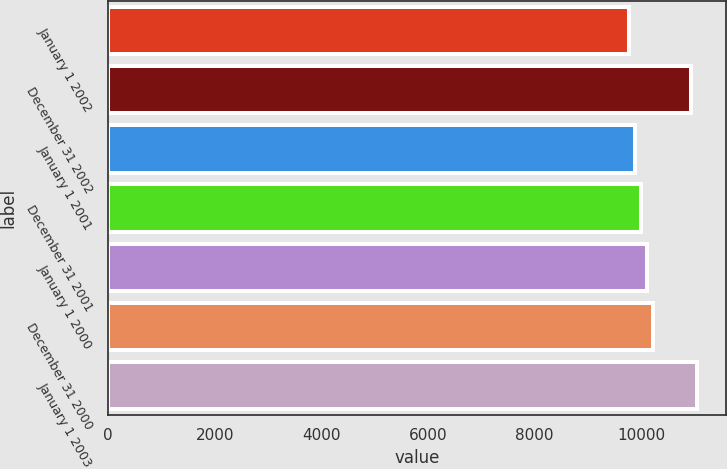<chart> <loc_0><loc_0><loc_500><loc_500><bar_chart><fcel>January 1 2002<fcel>December 31 2002<fcel>January 1 2001<fcel>December 31 2001<fcel>January 1 2000<fcel>December 31 2000<fcel>January 1 2003<nl><fcel>9768<fcel>10930<fcel>9884.2<fcel>10000.4<fcel>10116.6<fcel>10232.8<fcel>11046.2<nl></chart> 